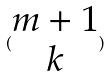<formula> <loc_0><loc_0><loc_500><loc_500>( \begin{matrix} m + 1 \\ k \end{matrix} )</formula> 